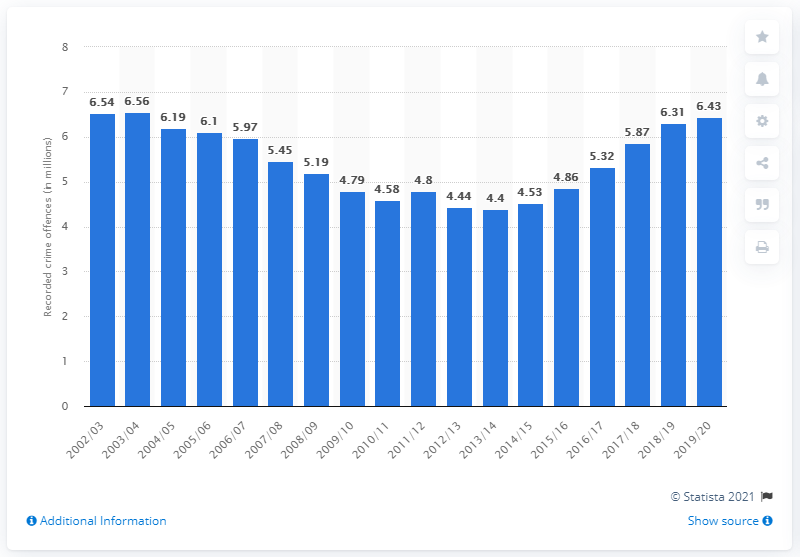Mention a couple of crucial points in this snapshot. In the 2019/2020 fiscal year, there were a total of 6.43 million crime offences reported in the UK. In 2013/2014, a total of 4.4 crimes were recorded in the United Kingdom. 